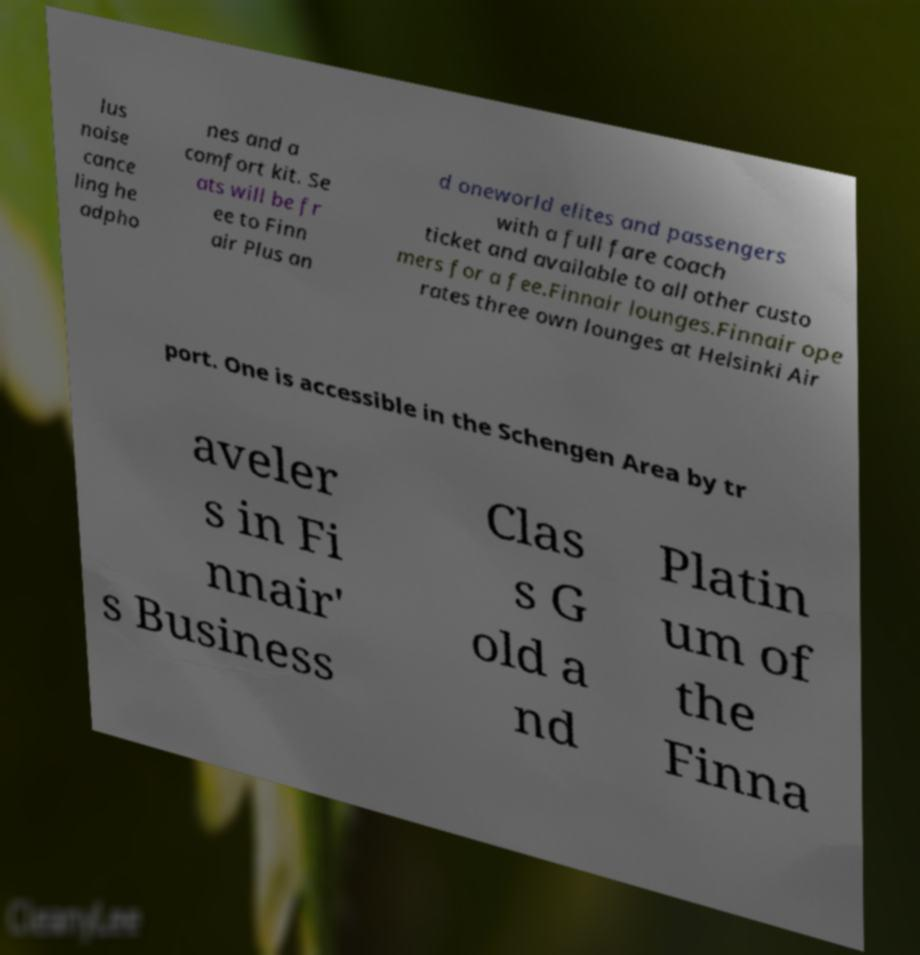I need the written content from this picture converted into text. Can you do that? lus noise cance ling he adpho nes and a comfort kit. Se ats will be fr ee to Finn air Plus an d oneworld elites and passengers with a full fare coach ticket and available to all other custo mers for a fee.Finnair lounges.Finnair ope rates three own lounges at Helsinki Air port. One is accessible in the Schengen Area by tr aveler s in Fi nnair' s Business Clas s G old a nd Platin um of the Finna 